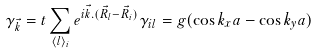<formula> <loc_0><loc_0><loc_500><loc_500>\gamma _ { \vec { k } } = t \sum _ { \langle l \rangle _ { i } } e ^ { i { \vec { k } } . ( \vec { R _ { l } } - \vec { R _ { i } } ) } \gamma _ { i l } = g ( \cos k _ { x } a - \cos k _ { y } a )</formula> 